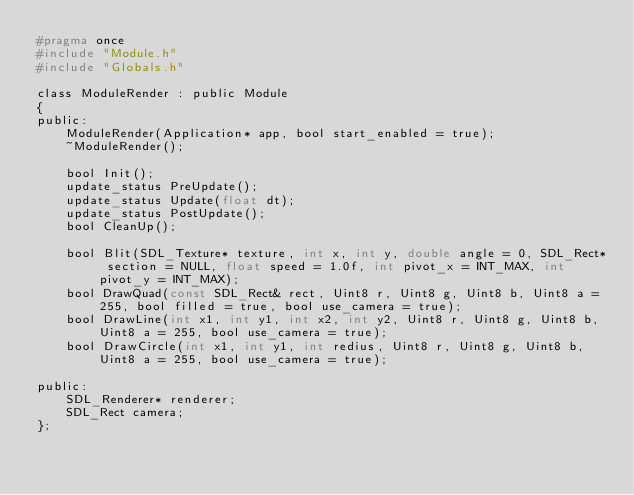Convert code to text. <code><loc_0><loc_0><loc_500><loc_500><_C_>#pragma once
#include "Module.h"
#include "Globals.h"

class ModuleRender : public Module
{
public:
	ModuleRender(Application* app, bool start_enabled = true);
	~ModuleRender();

	bool Init();
	update_status PreUpdate();
	update_status Update(float dt);
	update_status PostUpdate();
	bool CleanUp();

	bool Blit(SDL_Texture* texture, int x, int y, double angle = 0, SDL_Rect* section = NULL, float speed = 1.0f, int pivot_x = INT_MAX, int pivot_y = INT_MAX);
	bool DrawQuad(const SDL_Rect& rect, Uint8 r, Uint8 g, Uint8 b, Uint8 a = 255, bool filled = true, bool use_camera = true);
	bool DrawLine(int x1, int y1, int x2, int y2, Uint8 r, Uint8 g, Uint8 b, Uint8 a = 255, bool use_camera = true);
	bool DrawCircle(int x1, int y1, int redius, Uint8 r, Uint8 g, Uint8 b, Uint8 a = 255, bool use_camera = true);

public:
	SDL_Renderer* renderer;
	SDL_Rect camera;
};</code> 